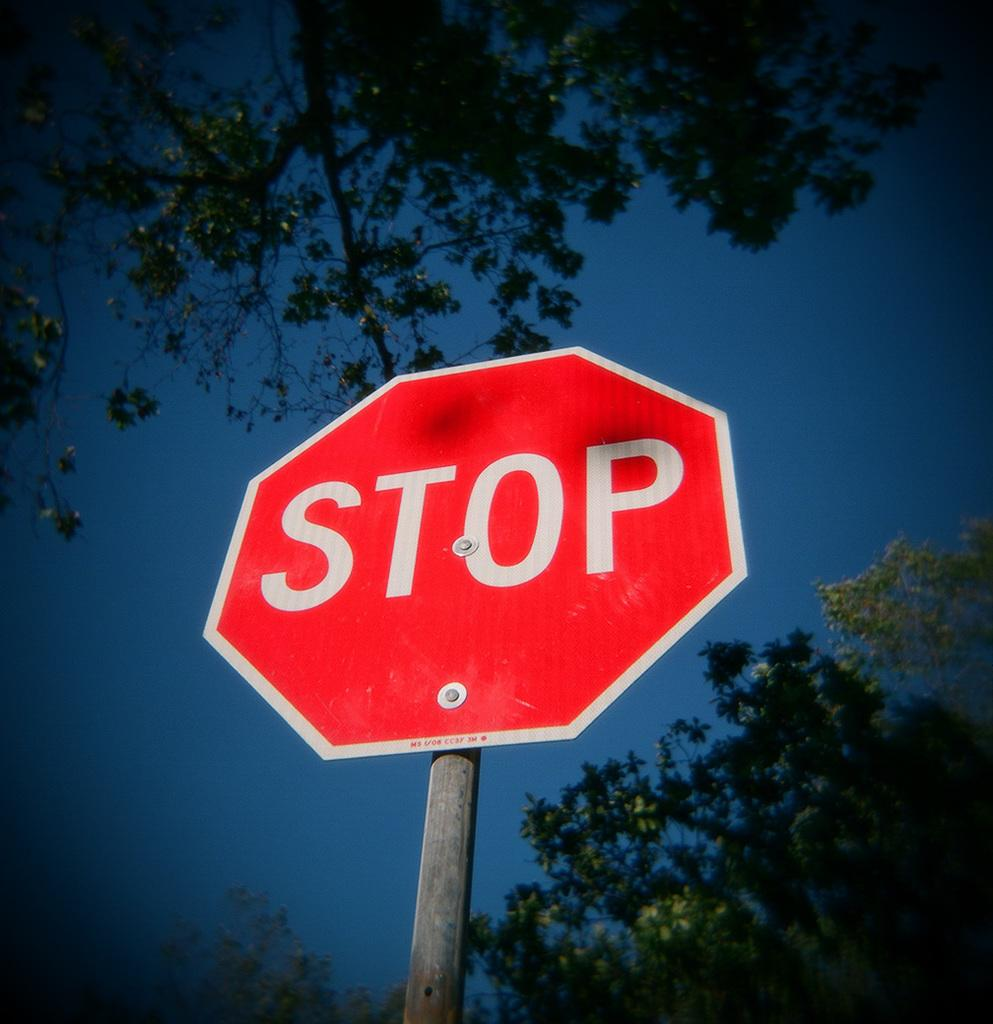<image>
Share a concise interpretation of the image provided. A STOP sign is placed on a street with sky and tree branches above it. 